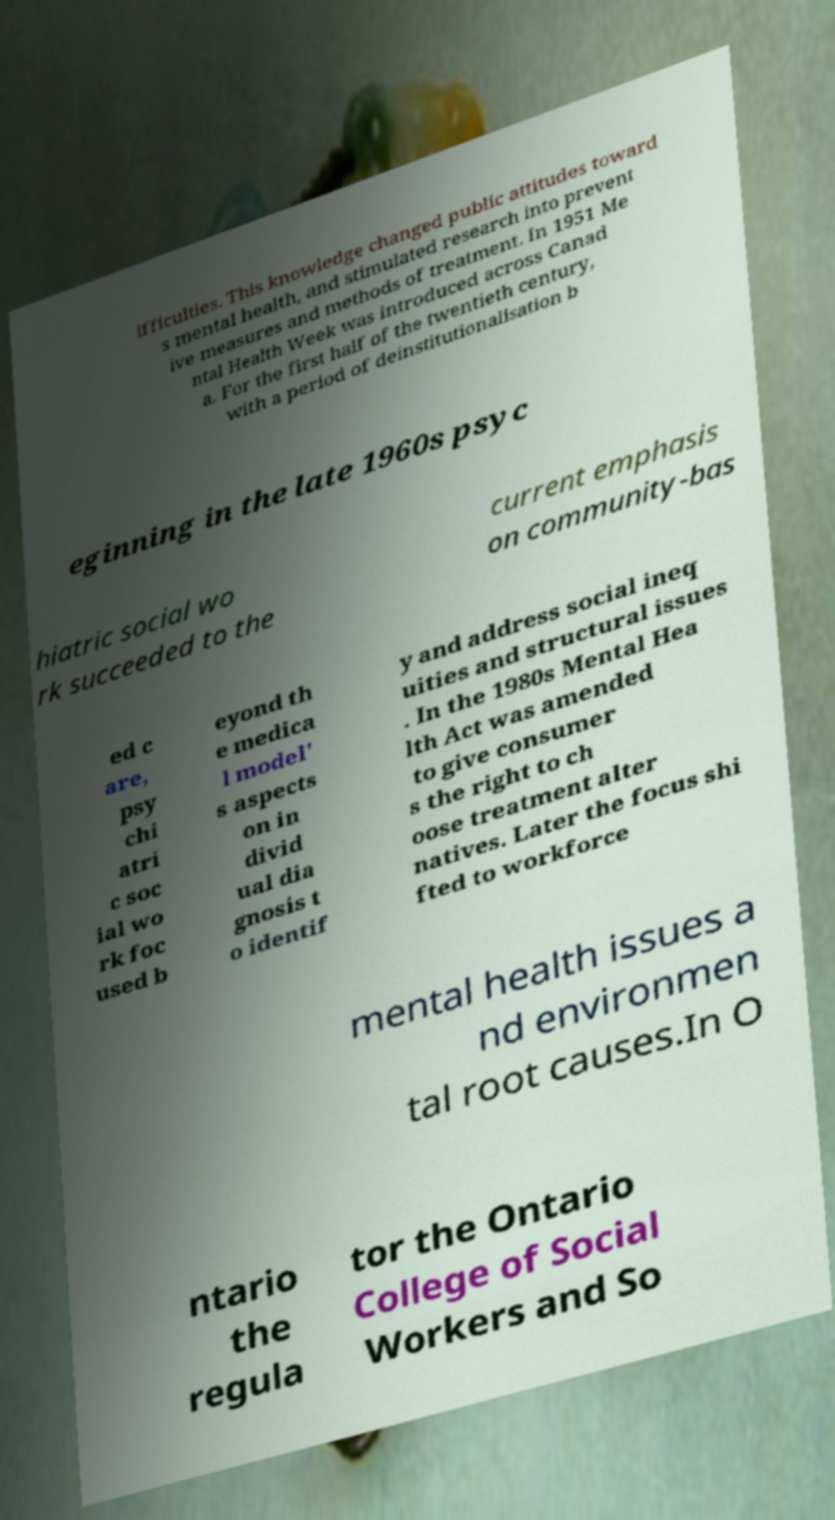Could you assist in decoding the text presented in this image and type it out clearly? ifficulties. This knowledge changed public attitudes toward s mental health, and stimulated research into prevent ive measures and methods of treatment. In 1951 Me ntal Health Week was introduced across Canad a. For the first half of the twentieth century, with a period of deinstitutionalisation b eginning in the late 1960s psyc hiatric social wo rk succeeded to the current emphasis on community-bas ed c are, psy chi atri c soc ial wo rk foc used b eyond th e medica l model' s aspects on in divid ual dia gnosis t o identif y and address social ineq uities and structural issues . In the 1980s Mental Hea lth Act was amended to give consumer s the right to ch oose treatment alter natives. Later the focus shi fted to workforce mental health issues a nd environmen tal root causes.In O ntario the regula tor the Ontario College of Social Workers and So 